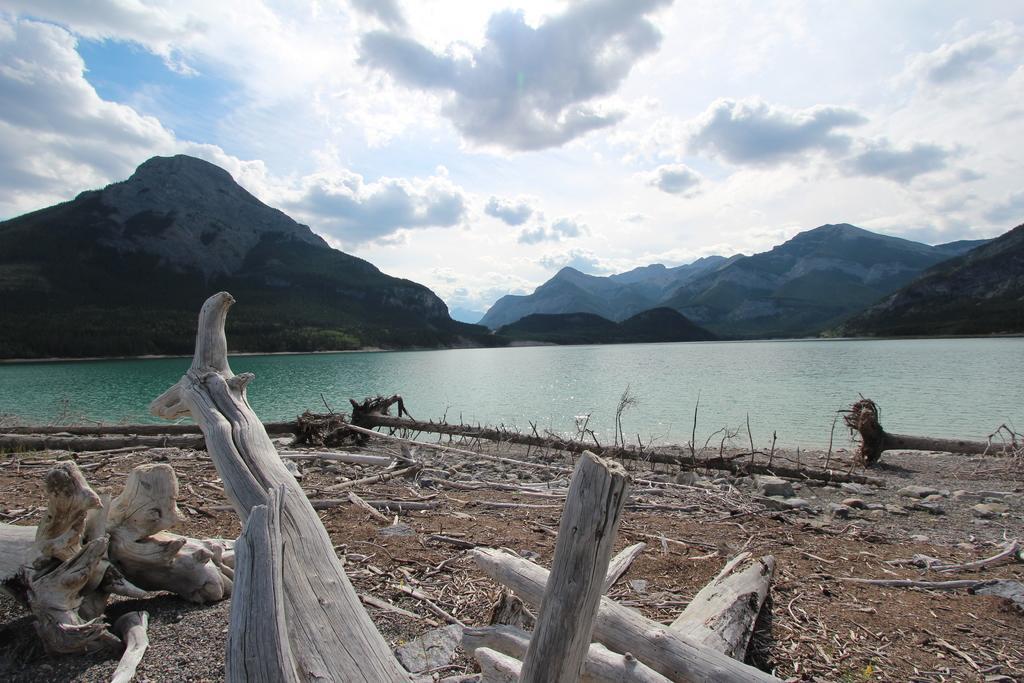Please provide a concise description of this image. In this image there are wood logs on the surface, in front of them there is a river, behind the river there are mountains. 